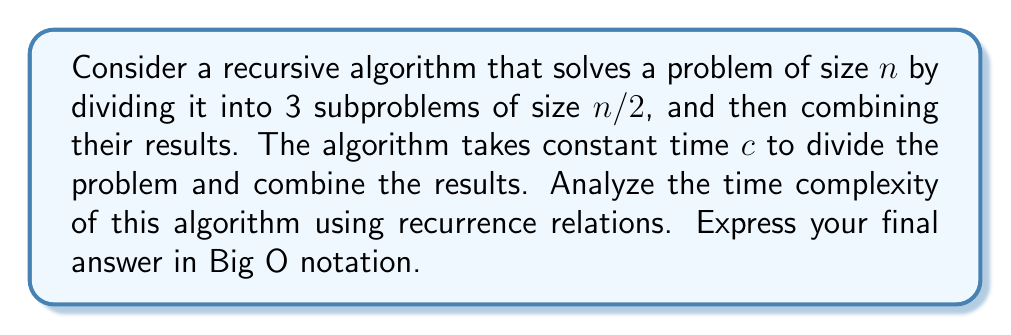Provide a solution to this math problem. Let's approach this step-by-step:

1) First, we need to formulate the recurrence relation. Let T(n) be the time complexity for a problem of size n. We can express T(n) as:

   $$T(n) = 3T(n/2) + c$$

   This is because we're dividing the problem into 3 subproblems of size n/2, and adding a constant time c for division and combination.

2) To solve this recurrence, we can use the Master Theorem. The Master Theorem states that for recurrences of the form:

   $$T(n) = aT(n/b) + f(n)$$

   Where a ≥ 1, b > 1, and f(n) is a positive function, the solution to the recurrence is:

   - If $f(n) = O(n^{\log_b a - \epsilon})$ for some constant $\epsilon > 0$, then $T(n) = \Theta(n^{\log_b a})$
   - If $f(n) = \Theta(n^{\log_b a})$, then $T(n) = \Theta(n^{\log_b a} \log n)$
   - If $f(n) = \Omega(n^{\log_b a + \epsilon})$ for some constant $\epsilon > 0$, and if $af(n/b) \leq kf(n)$ for some constant $k < 1$ and all sufficiently large n, then $T(n) = \Theta(f(n))$

3) In our case, a = 3, b = 2, and f(n) = c (a constant).

4) We need to calculate $\log_b a$:

   $$\log_2 3 \approx 1.58$$

5) Now, we compare f(n) = c with $n^{\log_2 3}$:

   c is O(1), which is $O(n^{\log_2 3 - \epsilon})$ for any $\epsilon > 0$

6) This falls under case 1 of the Master Theorem. Therefore:

   $$T(n) = \Theta(n^{\log_2 3})$$

7) In Big O notation, we can write this as:

   $$T(n) = O(n^{\log_2 3})$$

8) Note that $n^{\log_2 3} \approx n^{1.58}$, which is between O(n) and O(n^2).

This analysis shows that the algorithm has a time complexity that grows faster than linear but slower than quadratic.
Answer: $O(n^{\log_2 3})$ 